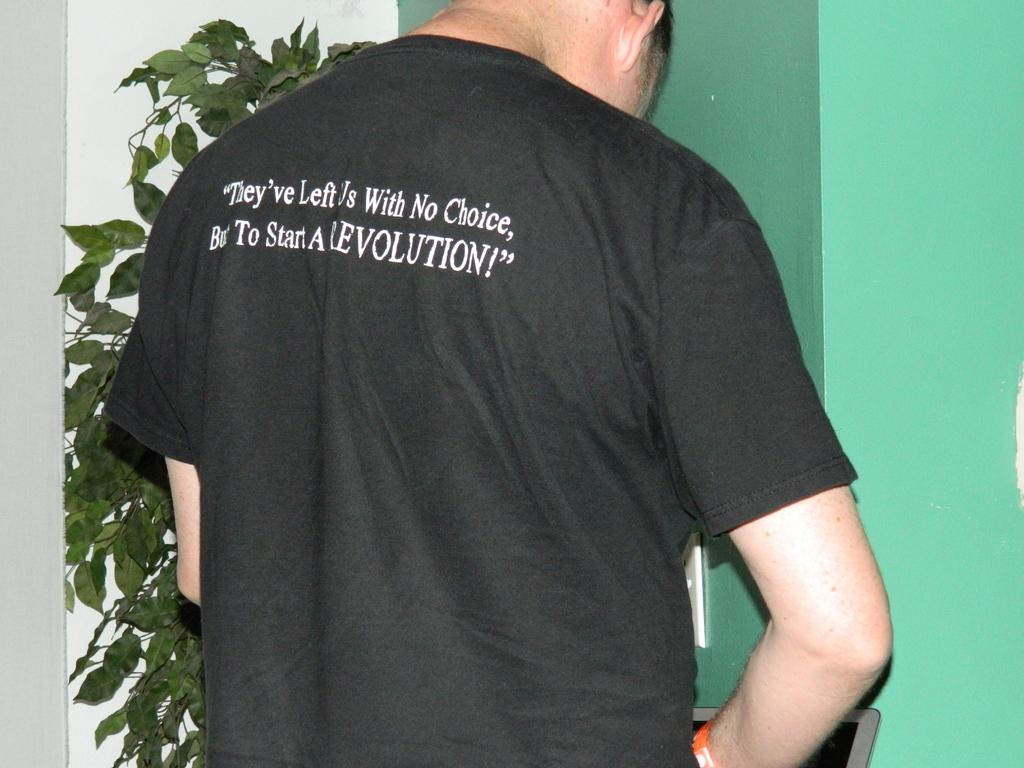<image>
Describe the image concisely. the back of a t-shirt reading "they've left us with no choice to start a REVOLUTION" 